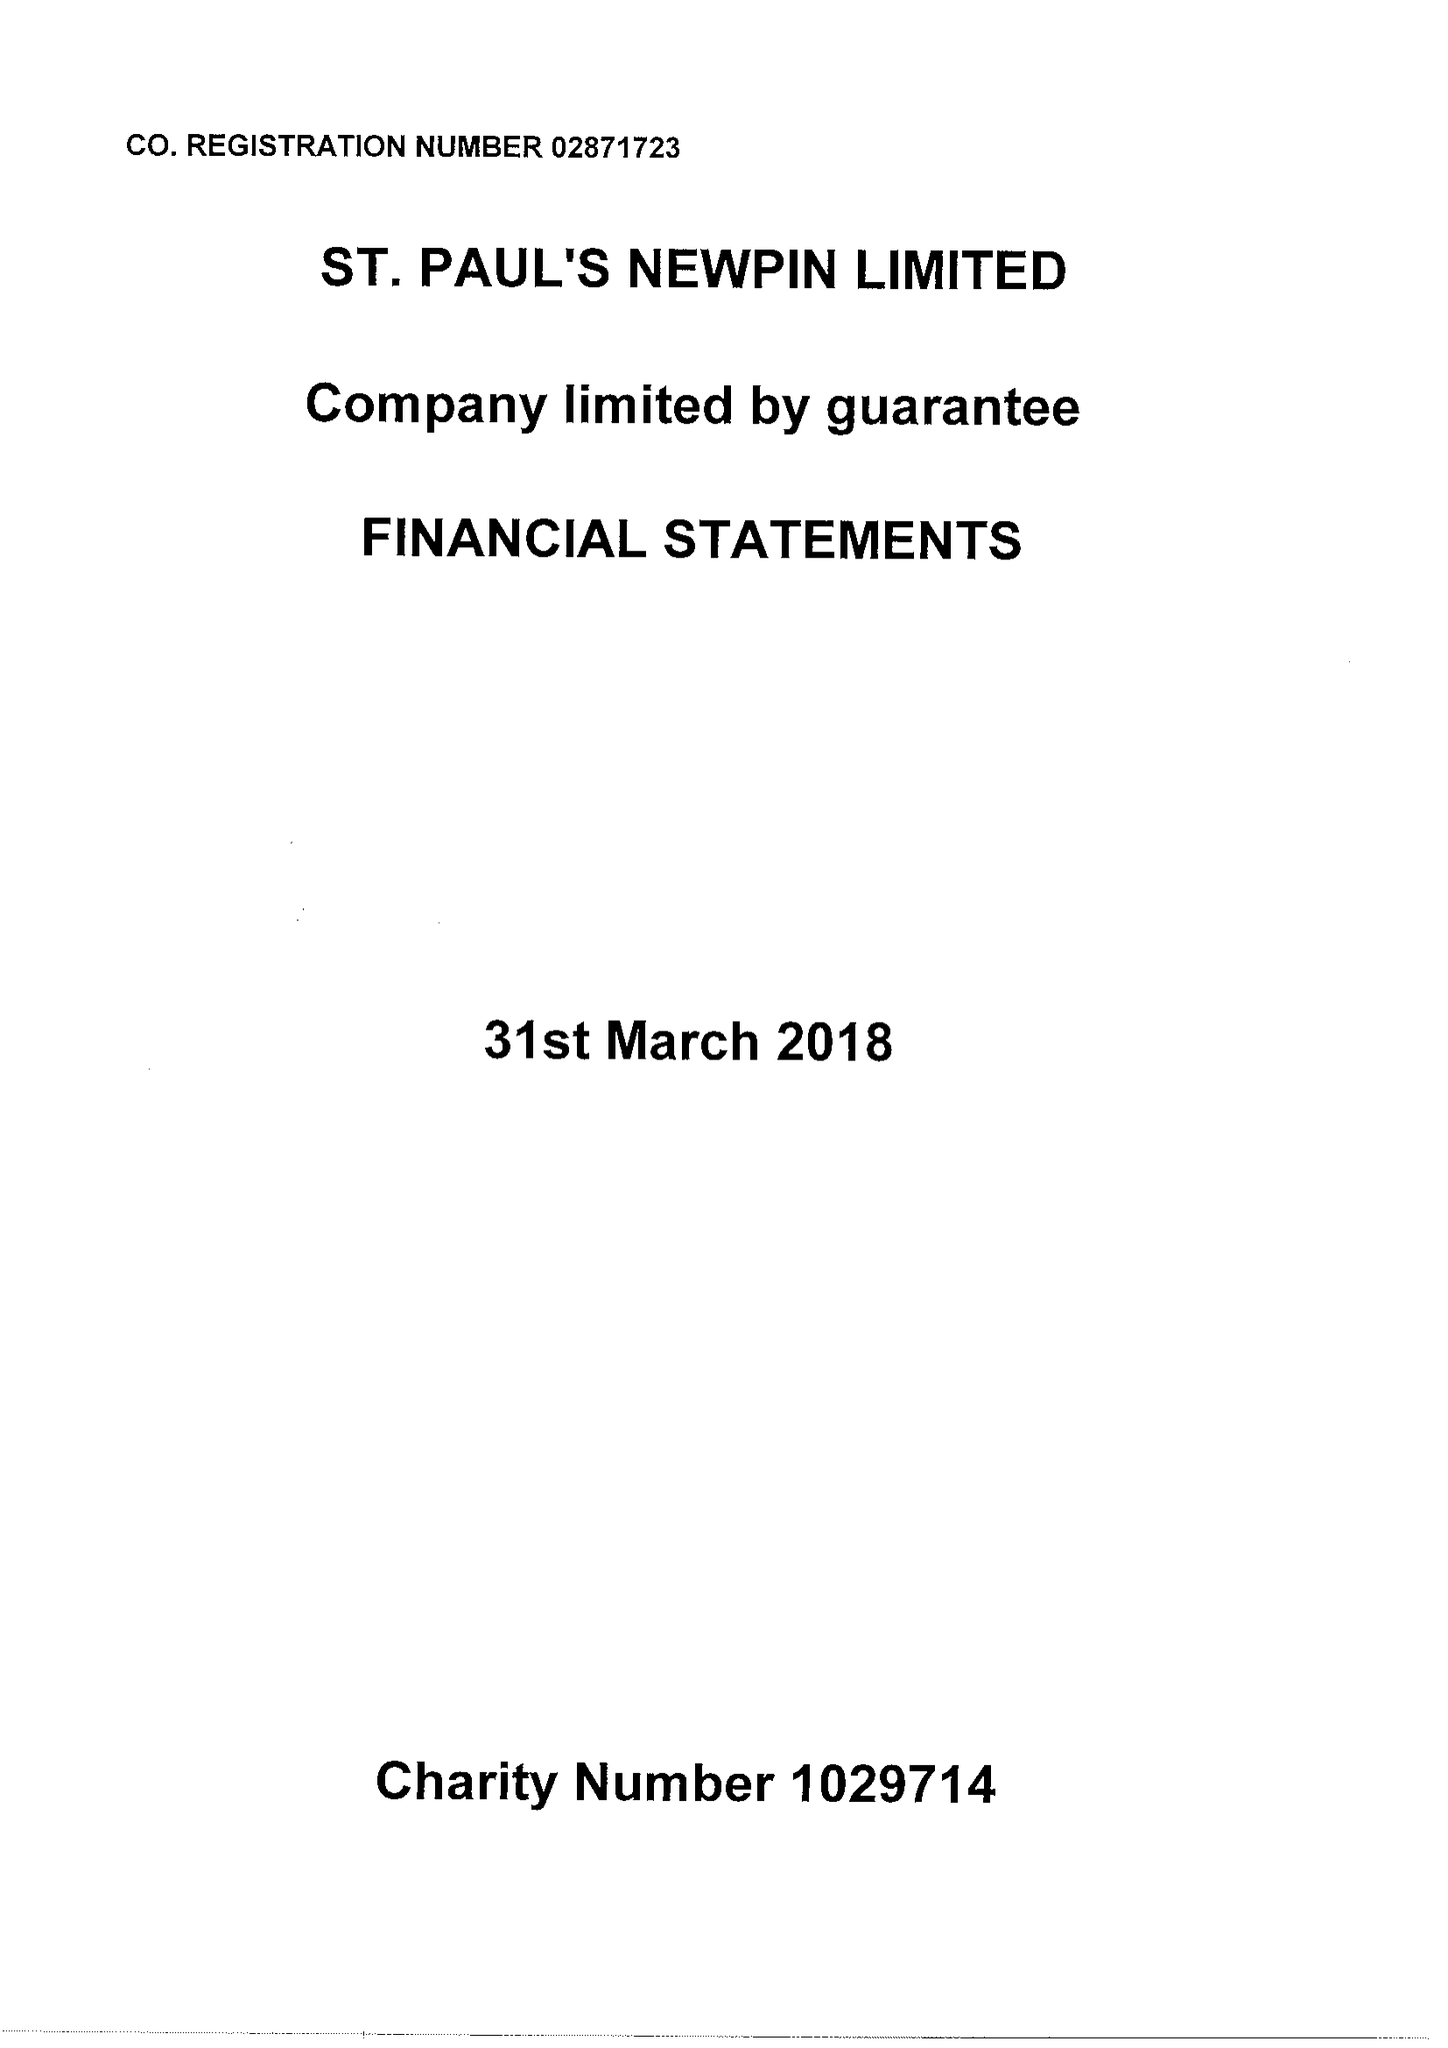What is the value for the income_annually_in_british_pounds?
Answer the question using a single word or phrase. 122283.00 